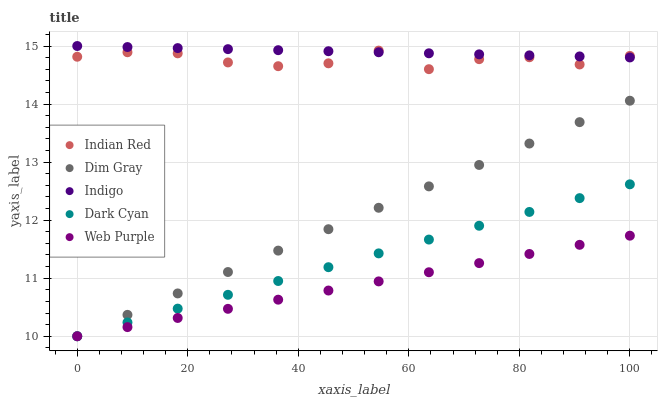Does Web Purple have the minimum area under the curve?
Answer yes or no. Yes. Does Indigo have the maximum area under the curve?
Answer yes or no. Yes. Does Dim Gray have the minimum area under the curve?
Answer yes or no. No. Does Dim Gray have the maximum area under the curve?
Answer yes or no. No. Is Web Purple the smoothest?
Answer yes or no. Yes. Is Indian Red the roughest?
Answer yes or no. Yes. Is Dim Gray the smoothest?
Answer yes or no. No. Is Dim Gray the roughest?
Answer yes or no. No. Does Dark Cyan have the lowest value?
Answer yes or no. Yes. Does Indigo have the lowest value?
Answer yes or no. No. Does Indigo have the highest value?
Answer yes or no. Yes. Does Dim Gray have the highest value?
Answer yes or no. No. Is Dim Gray less than Indian Red?
Answer yes or no. Yes. Is Indigo greater than Dim Gray?
Answer yes or no. Yes. Does Web Purple intersect Dim Gray?
Answer yes or no. Yes. Is Web Purple less than Dim Gray?
Answer yes or no. No. Is Web Purple greater than Dim Gray?
Answer yes or no. No. Does Dim Gray intersect Indian Red?
Answer yes or no. No. 